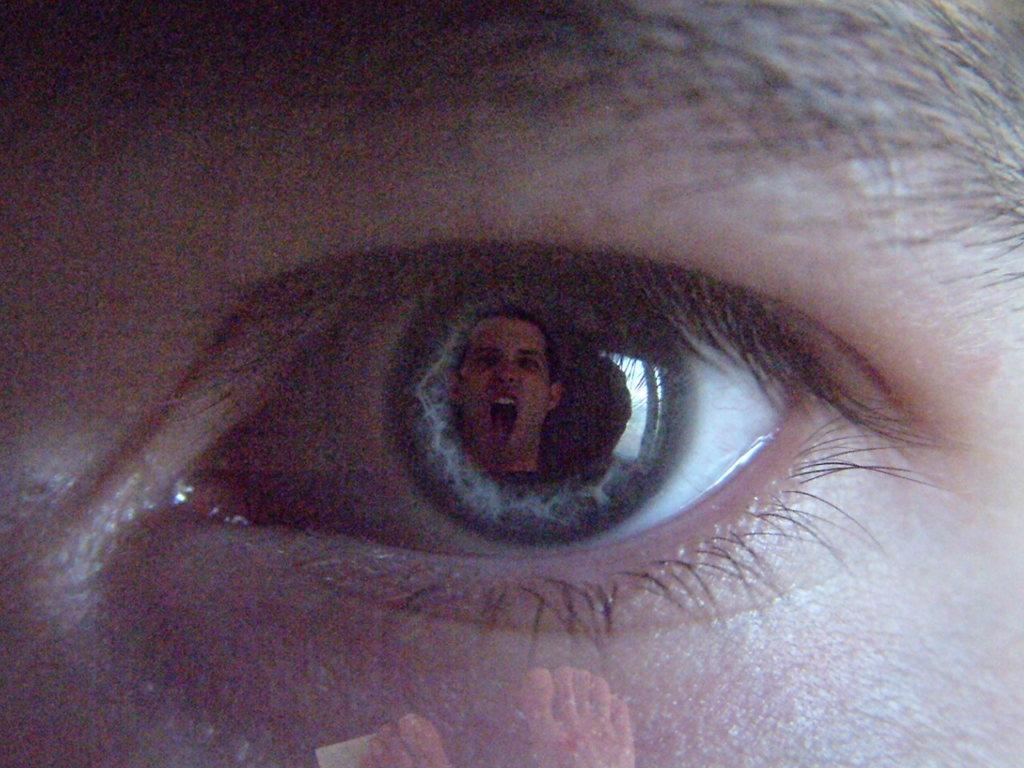What is the main subject of the image? The main subject of the image is an eye. Whose eye is it? The eye belongs to a person. What else can be seen in the image besides the eye? A person's face is visible from the eye, and there are legs of a person in the image. What type of star can be seen in the image? There is no star present in the image; it features a person's eye and face. What type of salt is sprinkled on the person's trousers in the image? There is no salt or trousers present in the image; it only shows a person's eye and face. 